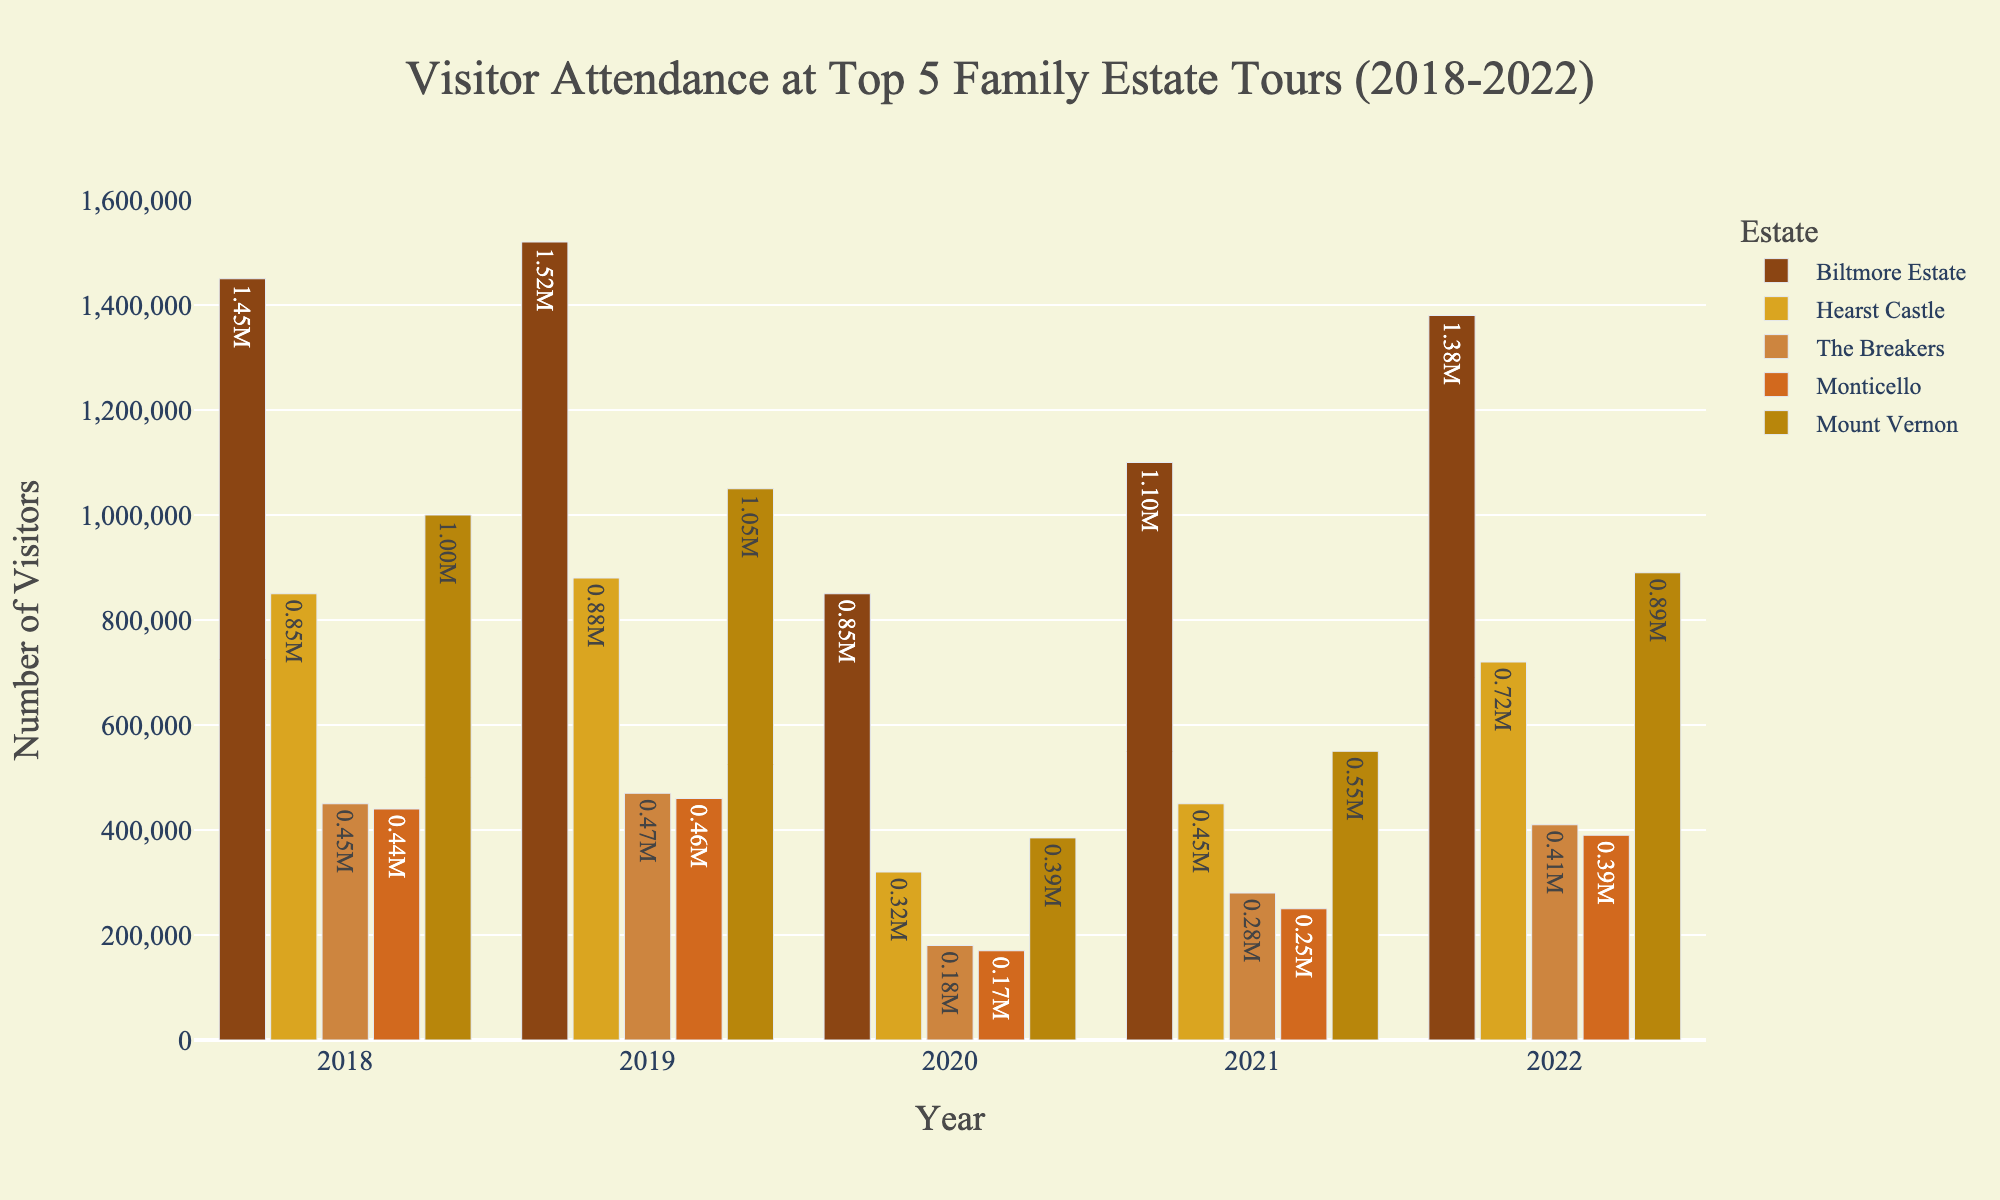What was the total number of visitors at Hearst Castle in 2018 and 2019 combined? Add the number of visitors in 2018 (850,000) and 2019 (880,000): 850,000 + 880,000 = 1,730,000.
Answer: 1,730,000 Which estate had the highest number of visitors in 2022? The bar for Biltmore Estate is the highest for 2022.
Answer: Biltmore Estate How did the visitor attendance at The Breakers in 2020 compare to 2021? In 2020, The Breakers had 180,000 visitors, while in 2021 it had 280,000 visitors. 280,000 - 180,000 = 100,000 more visitors in 2021.
Answer: 100,000 more in 2021 What was the average number of visitors for Monticello over the 5 years? Add the number of visitors for Monticello over the 5 years and then divide by 5: (440,000 + 460,000 + 170,000 + 250,000 + 390,000) / 5 = 342,000.
Answer: 342,000 Between 2018 and 2022, which year had the lowest visitor attendance for all the estates combined? Add the visitors for all estates for each year: 2018: 3,190,000, 2019: 3,420,000, 2020: 1,905,000, 2021: 2,530,000, 2022: 3,410,000. The lowest sum is for 2020.
Answer: 2020 How did the visitor counts at Mount Vernon change from 2018 to 2022? Subtract the number of visitors in 2018 from 2022: 890,000 - 1,000,000 = -110,000. This indicates a decrease of 110,000 visitors.
Answer: Decreased by 110,000 Which two estates had the smallest difference in visitor numbers in 2019? Calculate the differences between each pair: Biltmore-Hearst: 640,000, Biltmore-Breakers: 1,050,000, Biltmore-Monticello: 1,060,000, Biltmore-Mount Vernon: 470,000, Hearst-Breakers: 410,000, Hearst-Monticello: 420,000, Hearst-Mount Vernon: 170,000, Breakers-Monticello: 10,000, Breakers-Mount Vernon: 530,000, Monticello-Mount Vernon: 540,000. The smallest difference is between The Breakers and Monticello: 10,000.
Answer: The Breakers and Monticello What was the median visitor count among all estates in 2021? Order the visitor counts for 2021: 250,000 (Monticello), 280,000 (The Breakers), 450,000 (Hearst Castle), 550,000 (Mount Vernon), 1,100,000 (Biltmore Estate). The median value is 450,000.
Answer: 450,000 Identify the estate that recovered the most in visitor numbers from 2020 to 2022 and the amount of recovery. Subtract the 2020 visitors from the 2022 visitors for each estate: Biltmore: 1,380,000 - 850,000 = 530,000, Hearst: 720,000 - 320,000 = 400,000, Breakers: 410,000 - 180,000 = 230,000, Monticello: 390,000 - 170,000 = 220,000, Mount Vernon: 890,000 - 385,000 = 505,000. The estate with the most recovery is Biltmore Estate.
Answer: Biltmore Estate, 530,000 